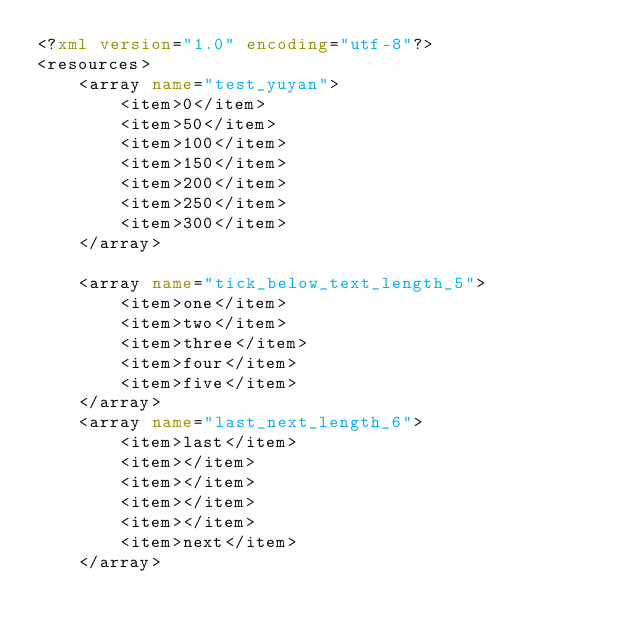<code> <loc_0><loc_0><loc_500><loc_500><_XML_><?xml version="1.0" encoding="utf-8"?>
<resources>
    <array name="test_yuyan">
        <item>0</item>
        <item>50</item>
        <item>100</item>
        <item>150</item>
        <item>200</item>
        <item>250</item>
        <item>300</item>
    </array>

    <array name="tick_below_text_length_5">
        <item>one</item>
        <item>two</item>
        <item>three</item>
        <item>four</item>
        <item>five</item>
    </array>
    <array name="last_next_length_6">
        <item>last</item>
        <item></item>
        <item></item>
        <item></item>
        <item></item>
        <item>next</item>
    </array></code> 